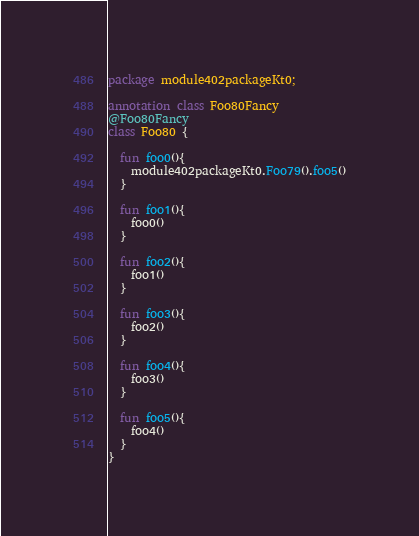Convert code to text. <code><loc_0><loc_0><loc_500><loc_500><_Kotlin_>package module402packageKt0;

annotation class Foo80Fancy
@Foo80Fancy
class Foo80 {

  fun foo0(){
    module402packageKt0.Foo79().foo5()
  }

  fun foo1(){
    foo0()
  }

  fun foo2(){
    foo1()
  }

  fun foo3(){
    foo2()
  }

  fun foo4(){
    foo3()
  }

  fun foo5(){
    foo4()
  }
}</code> 